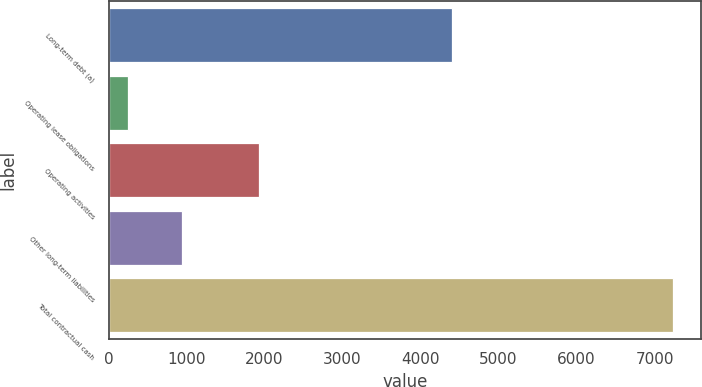<chart> <loc_0><loc_0><loc_500><loc_500><bar_chart><fcel>Long-term debt (a)<fcel>Operating lease obligations<fcel>Operating activities<fcel>Other long-term liabilities<fcel>Total contractual cash<nl><fcel>4400<fcel>248<fcel>1933<fcel>946.4<fcel>7232<nl></chart> 